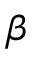Convert formula to latex. <formula><loc_0><loc_0><loc_500><loc_500>\beta</formula> 